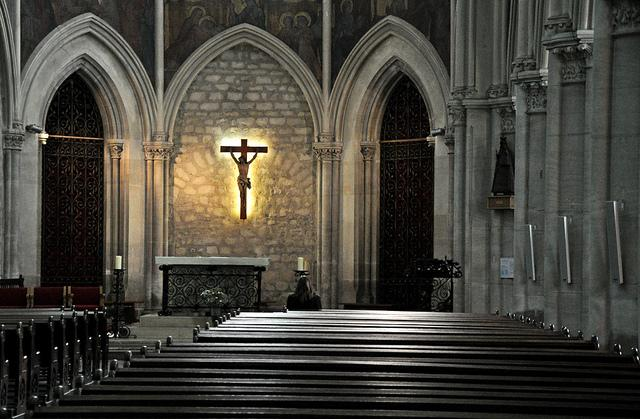What is she doing?

Choices:
A) resting
B) praying
C) hiding
D) eating praying 